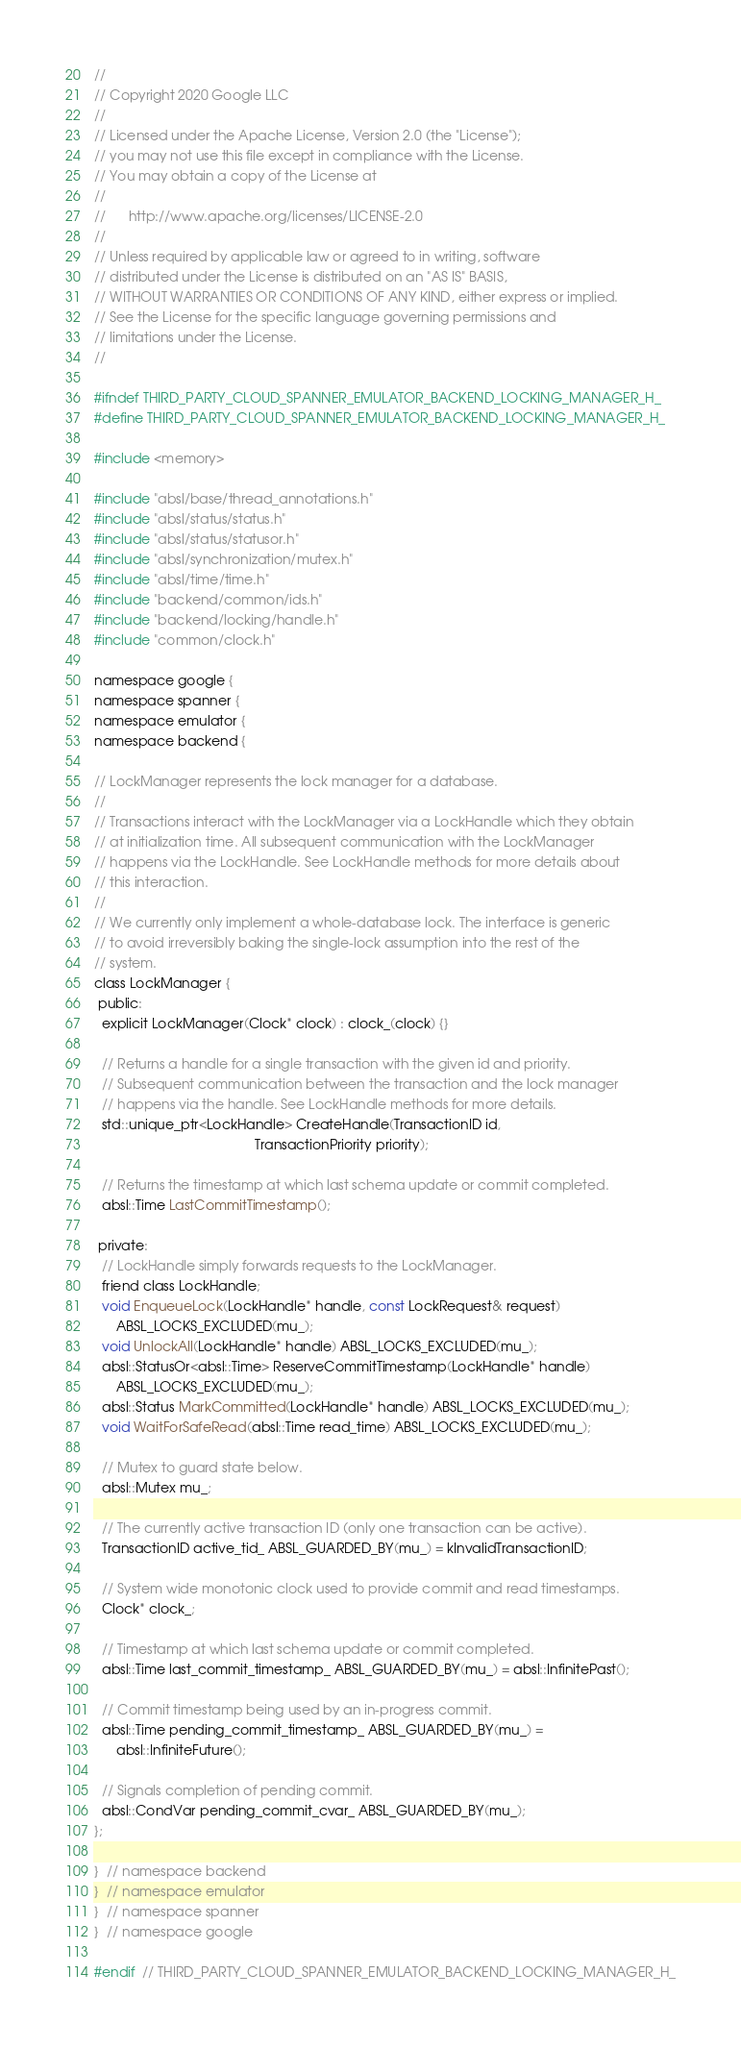Convert code to text. <code><loc_0><loc_0><loc_500><loc_500><_C_>//
// Copyright 2020 Google LLC
//
// Licensed under the Apache License, Version 2.0 (the "License");
// you may not use this file except in compliance with the License.
// You may obtain a copy of the License at
//
//      http://www.apache.org/licenses/LICENSE-2.0
//
// Unless required by applicable law or agreed to in writing, software
// distributed under the License is distributed on an "AS IS" BASIS,
// WITHOUT WARRANTIES OR CONDITIONS OF ANY KIND, either express or implied.
// See the License for the specific language governing permissions and
// limitations under the License.
//

#ifndef THIRD_PARTY_CLOUD_SPANNER_EMULATOR_BACKEND_LOCKING_MANAGER_H_
#define THIRD_PARTY_CLOUD_SPANNER_EMULATOR_BACKEND_LOCKING_MANAGER_H_

#include <memory>

#include "absl/base/thread_annotations.h"
#include "absl/status/status.h"
#include "absl/status/statusor.h"
#include "absl/synchronization/mutex.h"
#include "absl/time/time.h"
#include "backend/common/ids.h"
#include "backend/locking/handle.h"
#include "common/clock.h"

namespace google {
namespace spanner {
namespace emulator {
namespace backend {

// LockManager represents the lock manager for a database.
//
// Transactions interact with the LockManager via a LockHandle which they obtain
// at initialization time. All subsequent communication with the LockManager
// happens via the LockHandle. See LockHandle methods for more details about
// this interaction.
//
// We currently only implement a whole-database lock. The interface is generic
// to avoid irreversibly baking the single-lock assumption into the rest of the
// system.
class LockManager {
 public:
  explicit LockManager(Clock* clock) : clock_(clock) {}

  // Returns a handle for a single transaction with the given id and priority.
  // Subsequent communication between the transaction and the lock manager
  // happens via the handle. See LockHandle methods for more details.
  std::unique_ptr<LockHandle> CreateHandle(TransactionID id,
                                           TransactionPriority priority);

  // Returns the timestamp at which last schema update or commit completed.
  absl::Time LastCommitTimestamp();

 private:
  // LockHandle simply forwards requests to the LockManager.
  friend class LockHandle;
  void EnqueueLock(LockHandle* handle, const LockRequest& request)
      ABSL_LOCKS_EXCLUDED(mu_);
  void UnlockAll(LockHandle* handle) ABSL_LOCKS_EXCLUDED(mu_);
  absl::StatusOr<absl::Time> ReserveCommitTimestamp(LockHandle* handle)
      ABSL_LOCKS_EXCLUDED(mu_);
  absl::Status MarkCommitted(LockHandle* handle) ABSL_LOCKS_EXCLUDED(mu_);
  void WaitForSafeRead(absl::Time read_time) ABSL_LOCKS_EXCLUDED(mu_);

  // Mutex to guard state below.
  absl::Mutex mu_;

  // The currently active transaction ID (only one transaction can be active).
  TransactionID active_tid_ ABSL_GUARDED_BY(mu_) = kInvalidTransactionID;

  // System wide monotonic clock used to provide commit and read timestamps.
  Clock* clock_;

  // Timestamp at which last schema update or commit completed.
  absl::Time last_commit_timestamp_ ABSL_GUARDED_BY(mu_) = absl::InfinitePast();

  // Commit timestamp being used by an in-progress commit.
  absl::Time pending_commit_timestamp_ ABSL_GUARDED_BY(mu_) =
      absl::InfiniteFuture();

  // Signals completion of pending commit.
  absl::CondVar pending_commit_cvar_ ABSL_GUARDED_BY(mu_);
};

}  // namespace backend
}  // namespace emulator
}  // namespace spanner
}  // namespace google

#endif  // THIRD_PARTY_CLOUD_SPANNER_EMULATOR_BACKEND_LOCKING_MANAGER_H_
</code> 